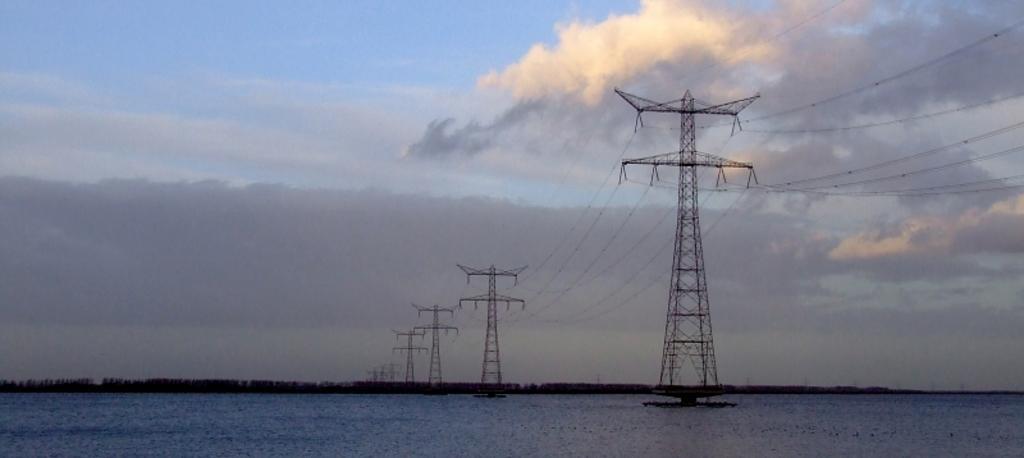In one or two sentences, can you explain what this image depicts? In this image we can see electric poles, electric cables, water, trees and sky with clouds. 